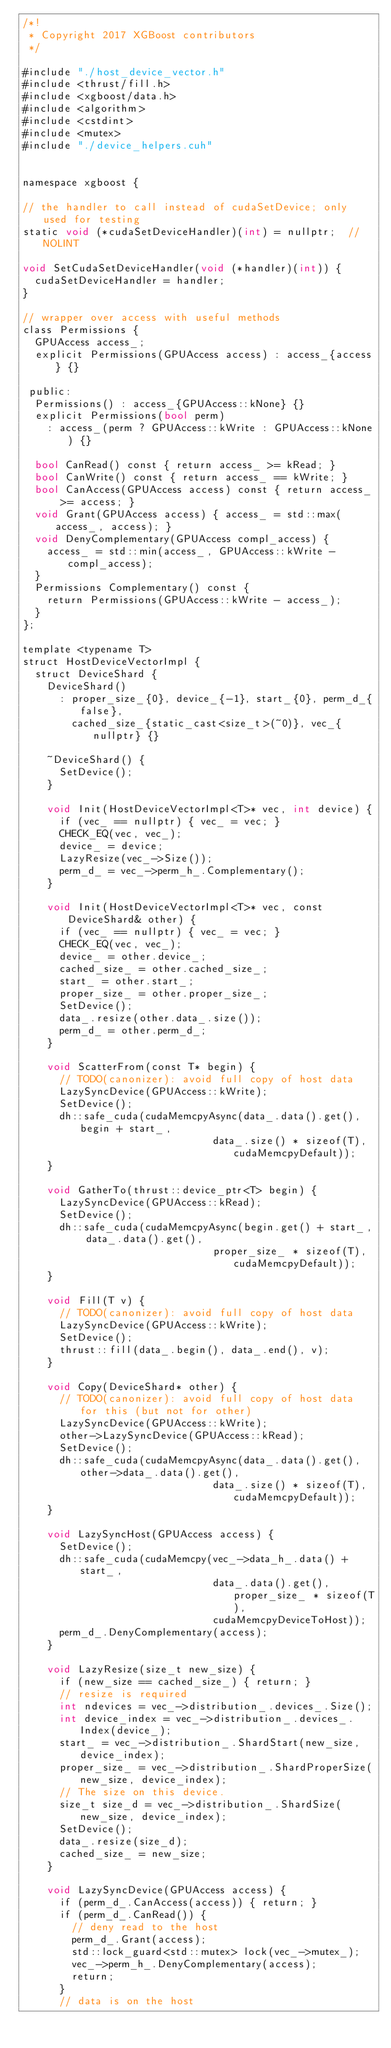Convert code to text. <code><loc_0><loc_0><loc_500><loc_500><_Cuda_>/*!
 * Copyright 2017 XGBoost contributors
 */

#include "./host_device_vector.h"
#include <thrust/fill.h>
#include <xgboost/data.h>
#include <algorithm>
#include <cstdint>
#include <mutex>
#include "./device_helpers.cuh"


namespace xgboost {

// the handler to call instead of cudaSetDevice; only used for testing
static void (*cudaSetDeviceHandler)(int) = nullptr;  // NOLINT

void SetCudaSetDeviceHandler(void (*handler)(int)) {
  cudaSetDeviceHandler = handler;
}

// wrapper over access with useful methods
class Permissions {
  GPUAccess access_;
  explicit Permissions(GPUAccess access) : access_{access} {}

 public:
  Permissions() : access_{GPUAccess::kNone} {}
  explicit Permissions(bool perm)
    : access_(perm ? GPUAccess::kWrite : GPUAccess::kNone) {}

  bool CanRead() const { return access_ >= kRead; }
  bool CanWrite() const { return access_ == kWrite; }
  bool CanAccess(GPUAccess access) const { return access_ >= access; }
  void Grant(GPUAccess access) { access_ = std::max(access_, access); }
  void DenyComplementary(GPUAccess compl_access) {
    access_ = std::min(access_, GPUAccess::kWrite - compl_access);
  }
  Permissions Complementary() const {
    return Permissions(GPUAccess::kWrite - access_);
  }
};

template <typename T>
struct HostDeviceVectorImpl {
  struct DeviceShard {
    DeviceShard()
      : proper_size_{0}, device_{-1}, start_{0}, perm_d_{false},
        cached_size_{static_cast<size_t>(~0)}, vec_{nullptr} {}

    ~DeviceShard() {
      SetDevice();
    }

    void Init(HostDeviceVectorImpl<T>* vec, int device) {
      if (vec_ == nullptr) { vec_ = vec; }
      CHECK_EQ(vec, vec_);
      device_ = device;
      LazyResize(vec_->Size());
      perm_d_ = vec_->perm_h_.Complementary();
    }

    void Init(HostDeviceVectorImpl<T>* vec, const DeviceShard& other) {
      if (vec_ == nullptr) { vec_ = vec; }
      CHECK_EQ(vec, vec_);
      device_ = other.device_;
      cached_size_ = other.cached_size_;
      start_ = other.start_;
      proper_size_ = other.proper_size_;
      SetDevice();
      data_.resize(other.data_.size());
      perm_d_ = other.perm_d_;
    }

    void ScatterFrom(const T* begin) {
      // TODO(canonizer): avoid full copy of host data
      LazySyncDevice(GPUAccess::kWrite);
      SetDevice();
      dh::safe_cuda(cudaMemcpyAsync(data_.data().get(), begin + start_,
                               data_.size() * sizeof(T), cudaMemcpyDefault));
    }

    void GatherTo(thrust::device_ptr<T> begin) {
      LazySyncDevice(GPUAccess::kRead);
      SetDevice();
      dh::safe_cuda(cudaMemcpyAsync(begin.get() + start_, data_.data().get(),
                               proper_size_ * sizeof(T), cudaMemcpyDefault));
    }

    void Fill(T v) {
      // TODO(canonizer): avoid full copy of host data
      LazySyncDevice(GPUAccess::kWrite);
      SetDevice();
      thrust::fill(data_.begin(), data_.end(), v);
    }

    void Copy(DeviceShard* other) {
      // TODO(canonizer): avoid full copy of host data for this (but not for other)
      LazySyncDevice(GPUAccess::kWrite);
      other->LazySyncDevice(GPUAccess::kRead);
      SetDevice();
      dh::safe_cuda(cudaMemcpyAsync(data_.data().get(), other->data_.data().get(),
                               data_.size() * sizeof(T), cudaMemcpyDefault));
    }

    void LazySyncHost(GPUAccess access) {
      SetDevice();
      dh::safe_cuda(cudaMemcpy(vec_->data_h_.data() + start_,
                               data_.data().get(),  proper_size_ * sizeof(T),
                               cudaMemcpyDeviceToHost));
      perm_d_.DenyComplementary(access);
    }

    void LazyResize(size_t new_size) {
      if (new_size == cached_size_) { return; }
      // resize is required
      int ndevices = vec_->distribution_.devices_.Size();
      int device_index = vec_->distribution_.devices_.Index(device_);
      start_ = vec_->distribution_.ShardStart(new_size, device_index);
      proper_size_ = vec_->distribution_.ShardProperSize(new_size, device_index);
      // The size on this device.
      size_t size_d = vec_->distribution_.ShardSize(new_size, device_index);
      SetDevice();
      data_.resize(size_d);
      cached_size_ = new_size;
    }

    void LazySyncDevice(GPUAccess access) {
      if (perm_d_.CanAccess(access)) { return; }
      if (perm_d_.CanRead()) {
        // deny read to the host
        perm_d_.Grant(access);
        std::lock_guard<std::mutex> lock(vec_->mutex_);
        vec_->perm_h_.DenyComplementary(access);
        return;
      }
      // data is on the host</code> 